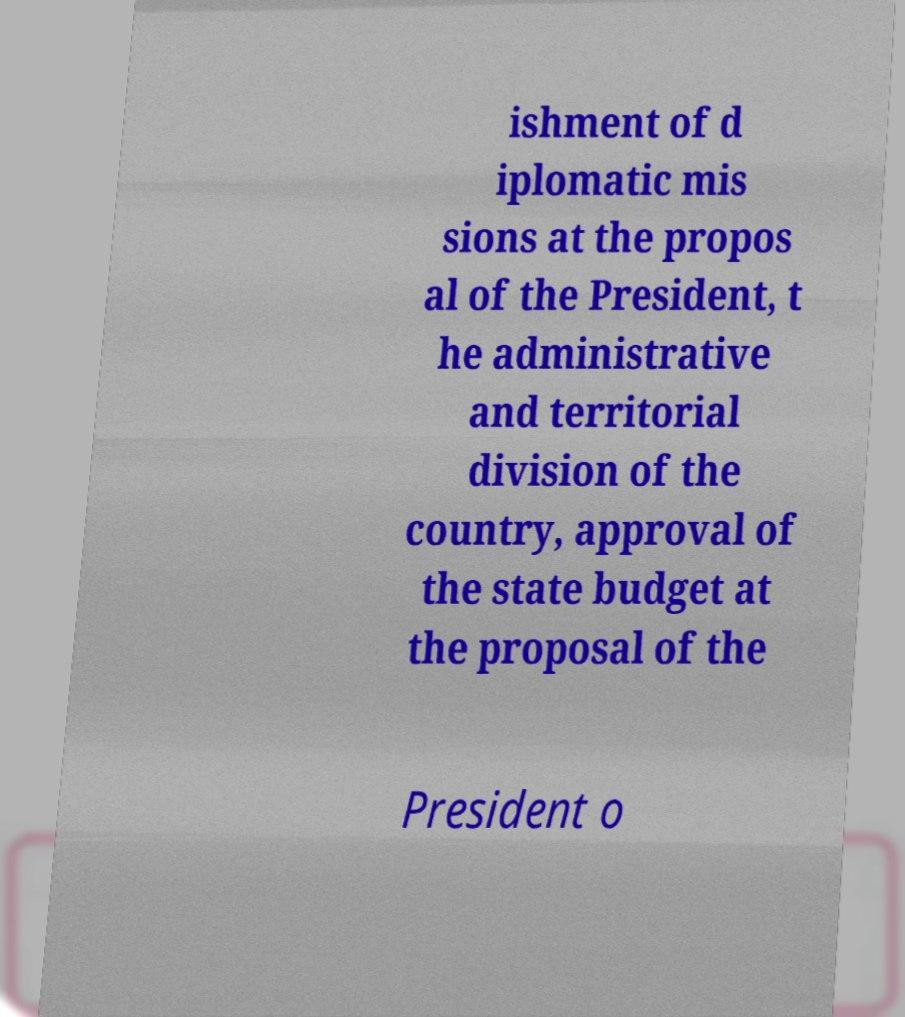For documentation purposes, I need the text within this image transcribed. Could you provide that? ishment of d iplomatic mis sions at the propos al of the President, t he administrative and territorial division of the country, approval of the state budget at the proposal of the President o 